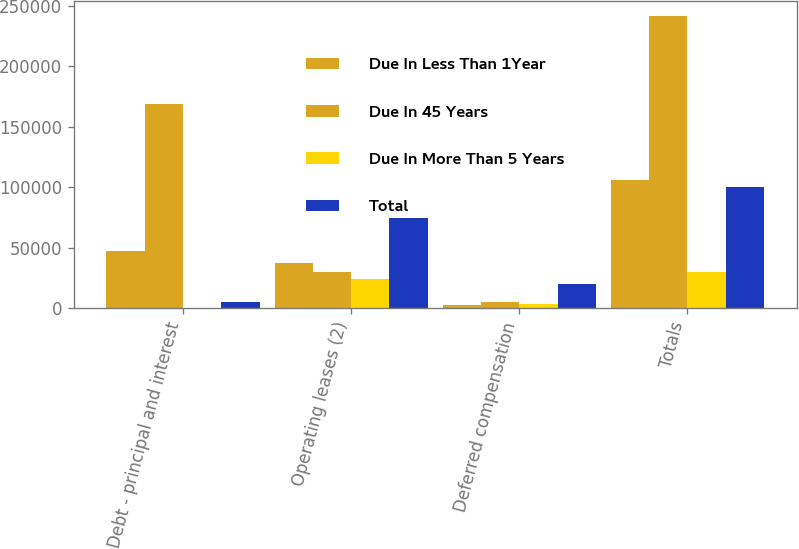Convert chart. <chart><loc_0><loc_0><loc_500><loc_500><stacked_bar_chart><ecel><fcel>Debt - principal and interest<fcel>Operating leases (2)<fcel>Deferred compensation<fcel>Totals<nl><fcel>Due In Less Than 1Year<fcel>47100<fcel>37820<fcel>2730<fcel>106375<nl><fcel>Due In 45 Years<fcel>168900<fcel>29840<fcel>5185<fcel>241940<nl><fcel>Due In More Than 5 Years<fcel>300<fcel>24590<fcel>3160<fcel>29840<nl><fcel>Total<fcel>5300<fcel>75055<fcel>20240<fcel>100595<nl></chart> 